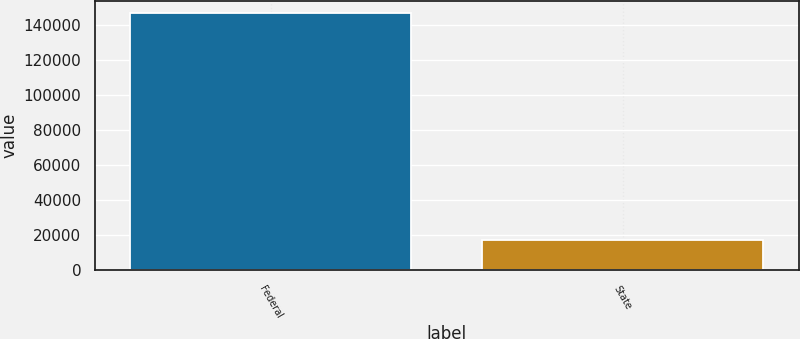<chart> <loc_0><loc_0><loc_500><loc_500><bar_chart><fcel>Federal<fcel>State<nl><fcel>146666<fcel>17055<nl></chart> 